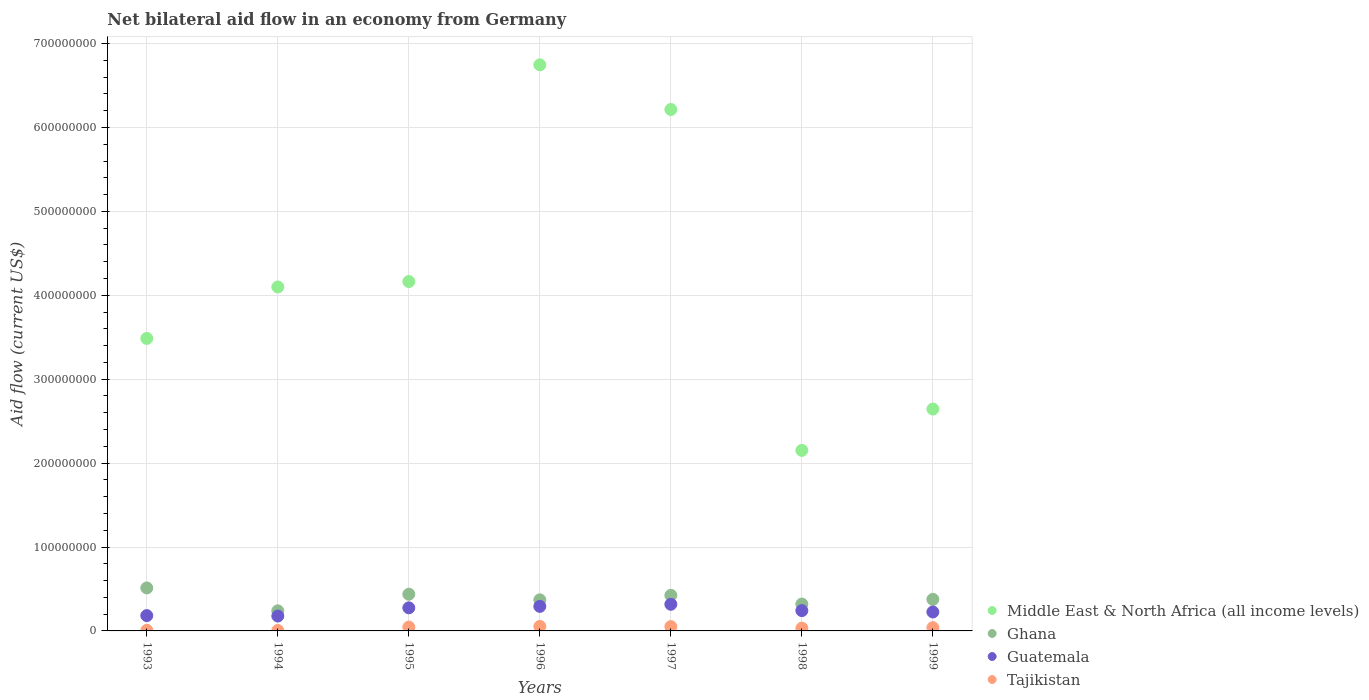How many different coloured dotlines are there?
Your response must be concise. 4. What is the net bilateral aid flow in Guatemala in 1999?
Your answer should be compact. 2.26e+07. Across all years, what is the maximum net bilateral aid flow in Ghana?
Make the answer very short. 5.12e+07. In which year was the net bilateral aid flow in Tajikistan minimum?
Give a very brief answer. 1994. What is the total net bilateral aid flow in Middle East & North Africa (all income levels) in the graph?
Your answer should be very brief. 2.95e+09. What is the difference between the net bilateral aid flow in Tajikistan in 1993 and that in 1996?
Offer a terse response. -4.63e+06. What is the difference between the net bilateral aid flow in Tajikistan in 1994 and the net bilateral aid flow in Middle East & North Africa (all income levels) in 1995?
Keep it short and to the point. -4.16e+08. What is the average net bilateral aid flow in Middle East & North Africa (all income levels) per year?
Your answer should be very brief. 4.21e+08. In the year 1994, what is the difference between the net bilateral aid flow in Guatemala and net bilateral aid flow in Tajikistan?
Provide a succinct answer. 1.72e+07. What is the ratio of the net bilateral aid flow in Guatemala in 1994 to that in 1999?
Your answer should be compact. 0.78. What is the difference between the highest and the second highest net bilateral aid flow in Guatemala?
Your answer should be very brief. 2.49e+06. What is the difference between the highest and the lowest net bilateral aid flow in Ghana?
Your answer should be very brief. 2.73e+07. Is it the case that in every year, the sum of the net bilateral aid flow in Middle East & North Africa (all income levels) and net bilateral aid flow in Guatemala  is greater than the net bilateral aid flow in Tajikistan?
Offer a terse response. Yes. Does the net bilateral aid flow in Middle East & North Africa (all income levels) monotonically increase over the years?
Your answer should be compact. No. Are the values on the major ticks of Y-axis written in scientific E-notation?
Provide a succinct answer. No. Does the graph contain any zero values?
Keep it short and to the point. No. How are the legend labels stacked?
Offer a terse response. Vertical. What is the title of the graph?
Provide a succinct answer. Net bilateral aid flow in an economy from Germany. What is the label or title of the X-axis?
Make the answer very short. Years. What is the label or title of the Y-axis?
Ensure brevity in your answer.  Aid flow (current US$). What is the Aid flow (current US$) of Middle East & North Africa (all income levels) in 1993?
Offer a terse response. 3.49e+08. What is the Aid flow (current US$) in Ghana in 1993?
Your answer should be very brief. 5.12e+07. What is the Aid flow (current US$) of Guatemala in 1993?
Give a very brief answer. 1.83e+07. What is the Aid flow (current US$) of Tajikistan in 1993?
Provide a short and direct response. 7.40e+05. What is the Aid flow (current US$) of Middle East & North Africa (all income levels) in 1994?
Your answer should be very brief. 4.10e+08. What is the Aid flow (current US$) in Ghana in 1994?
Give a very brief answer. 2.39e+07. What is the Aid flow (current US$) in Guatemala in 1994?
Provide a short and direct response. 1.77e+07. What is the Aid flow (current US$) of Tajikistan in 1994?
Make the answer very short. 5.50e+05. What is the Aid flow (current US$) of Middle East & North Africa (all income levels) in 1995?
Your answer should be compact. 4.16e+08. What is the Aid flow (current US$) in Ghana in 1995?
Offer a terse response. 4.37e+07. What is the Aid flow (current US$) in Guatemala in 1995?
Keep it short and to the point. 2.75e+07. What is the Aid flow (current US$) of Tajikistan in 1995?
Make the answer very short. 4.62e+06. What is the Aid flow (current US$) in Middle East & North Africa (all income levels) in 1996?
Make the answer very short. 6.75e+08. What is the Aid flow (current US$) in Ghana in 1996?
Ensure brevity in your answer.  3.71e+07. What is the Aid flow (current US$) of Guatemala in 1996?
Provide a short and direct response. 2.92e+07. What is the Aid flow (current US$) of Tajikistan in 1996?
Ensure brevity in your answer.  5.37e+06. What is the Aid flow (current US$) of Middle East & North Africa (all income levels) in 1997?
Keep it short and to the point. 6.21e+08. What is the Aid flow (current US$) in Ghana in 1997?
Make the answer very short. 4.24e+07. What is the Aid flow (current US$) in Guatemala in 1997?
Offer a very short reply. 3.17e+07. What is the Aid flow (current US$) of Tajikistan in 1997?
Make the answer very short. 5.13e+06. What is the Aid flow (current US$) in Middle East & North Africa (all income levels) in 1998?
Keep it short and to the point. 2.15e+08. What is the Aid flow (current US$) of Ghana in 1998?
Offer a very short reply. 3.20e+07. What is the Aid flow (current US$) in Guatemala in 1998?
Give a very brief answer. 2.42e+07. What is the Aid flow (current US$) in Tajikistan in 1998?
Provide a short and direct response. 3.32e+06. What is the Aid flow (current US$) of Middle East & North Africa (all income levels) in 1999?
Provide a succinct answer. 2.64e+08. What is the Aid flow (current US$) in Ghana in 1999?
Your answer should be compact. 3.76e+07. What is the Aid flow (current US$) in Guatemala in 1999?
Your answer should be compact. 2.26e+07. What is the Aid flow (current US$) in Tajikistan in 1999?
Provide a short and direct response. 3.91e+06. Across all years, what is the maximum Aid flow (current US$) of Middle East & North Africa (all income levels)?
Your answer should be compact. 6.75e+08. Across all years, what is the maximum Aid flow (current US$) in Ghana?
Give a very brief answer. 5.12e+07. Across all years, what is the maximum Aid flow (current US$) of Guatemala?
Your answer should be compact. 3.17e+07. Across all years, what is the maximum Aid flow (current US$) of Tajikistan?
Provide a succinct answer. 5.37e+06. Across all years, what is the minimum Aid flow (current US$) in Middle East & North Africa (all income levels)?
Give a very brief answer. 2.15e+08. Across all years, what is the minimum Aid flow (current US$) in Ghana?
Ensure brevity in your answer.  2.39e+07. Across all years, what is the minimum Aid flow (current US$) in Guatemala?
Ensure brevity in your answer.  1.77e+07. What is the total Aid flow (current US$) of Middle East & North Africa (all income levels) in the graph?
Your response must be concise. 2.95e+09. What is the total Aid flow (current US$) of Ghana in the graph?
Make the answer very short. 2.68e+08. What is the total Aid flow (current US$) of Guatemala in the graph?
Your answer should be very brief. 1.71e+08. What is the total Aid flow (current US$) in Tajikistan in the graph?
Provide a short and direct response. 2.36e+07. What is the difference between the Aid flow (current US$) in Middle East & North Africa (all income levels) in 1993 and that in 1994?
Make the answer very short. -6.13e+07. What is the difference between the Aid flow (current US$) of Ghana in 1993 and that in 1994?
Ensure brevity in your answer.  2.73e+07. What is the difference between the Aid flow (current US$) of Guatemala in 1993 and that in 1994?
Ensure brevity in your answer.  5.30e+05. What is the difference between the Aid flow (current US$) of Tajikistan in 1993 and that in 1994?
Your response must be concise. 1.90e+05. What is the difference between the Aid flow (current US$) of Middle East & North Africa (all income levels) in 1993 and that in 1995?
Keep it short and to the point. -6.78e+07. What is the difference between the Aid flow (current US$) in Ghana in 1993 and that in 1995?
Offer a terse response. 7.49e+06. What is the difference between the Aid flow (current US$) of Guatemala in 1993 and that in 1995?
Keep it short and to the point. -9.24e+06. What is the difference between the Aid flow (current US$) in Tajikistan in 1993 and that in 1995?
Your answer should be compact. -3.88e+06. What is the difference between the Aid flow (current US$) of Middle East & North Africa (all income levels) in 1993 and that in 1996?
Offer a terse response. -3.26e+08. What is the difference between the Aid flow (current US$) of Ghana in 1993 and that in 1996?
Provide a succinct answer. 1.42e+07. What is the difference between the Aid flow (current US$) of Guatemala in 1993 and that in 1996?
Offer a very short reply. -1.10e+07. What is the difference between the Aid flow (current US$) in Tajikistan in 1993 and that in 1996?
Make the answer very short. -4.63e+06. What is the difference between the Aid flow (current US$) in Middle East & North Africa (all income levels) in 1993 and that in 1997?
Offer a terse response. -2.73e+08. What is the difference between the Aid flow (current US$) of Ghana in 1993 and that in 1997?
Give a very brief answer. 8.83e+06. What is the difference between the Aid flow (current US$) in Guatemala in 1993 and that in 1997?
Provide a short and direct response. -1.35e+07. What is the difference between the Aid flow (current US$) in Tajikistan in 1993 and that in 1997?
Offer a very short reply. -4.39e+06. What is the difference between the Aid flow (current US$) in Middle East & North Africa (all income levels) in 1993 and that in 1998?
Your answer should be compact. 1.33e+08. What is the difference between the Aid flow (current US$) in Ghana in 1993 and that in 1998?
Your answer should be compact. 1.92e+07. What is the difference between the Aid flow (current US$) in Guatemala in 1993 and that in 1998?
Offer a terse response. -5.94e+06. What is the difference between the Aid flow (current US$) in Tajikistan in 1993 and that in 1998?
Offer a very short reply. -2.58e+06. What is the difference between the Aid flow (current US$) of Middle East & North Africa (all income levels) in 1993 and that in 1999?
Your answer should be compact. 8.42e+07. What is the difference between the Aid flow (current US$) in Ghana in 1993 and that in 1999?
Make the answer very short. 1.36e+07. What is the difference between the Aid flow (current US$) in Guatemala in 1993 and that in 1999?
Offer a terse response. -4.33e+06. What is the difference between the Aid flow (current US$) of Tajikistan in 1993 and that in 1999?
Provide a short and direct response. -3.17e+06. What is the difference between the Aid flow (current US$) in Middle East & North Africa (all income levels) in 1994 and that in 1995?
Your response must be concise. -6.46e+06. What is the difference between the Aid flow (current US$) in Ghana in 1994 and that in 1995?
Keep it short and to the point. -1.98e+07. What is the difference between the Aid flow (current US$) in Guatemala in 1994 and that in 1995?
Keep it short and to the point. -9.77e+06. What is the difference between the Aid flow (current US$) in Tajikistan in 1994 and that in 1995?
Provide a succinct answer. -4.07e+06. What is the difference between the Aid flow (current US$) of Middle East & North Africa (all income levels) in 1994 and that in 1996?
Your answer should be very brief. -2.65e+08. What is the difference between the Aid flow (current US$) in Ghana in 1994 and that in 1996?
Provide a short and direct response. -1.31e+07. What is the difference between the Aid flow (current US$) of Guatemala in 1994 and that in 1996?
Keep it short and to the point. -1.15e+07. What is the difference between the Aid flow (current US$) in Tajikistan in 1994 and that in 1996?
Provide a short and direct response. -4.82e+06. What is the difference between the Aid flow (current US$) of Middle East & North Africa (all income levels) in 1994 and that in 1997?
Your response must be concise. -2.11e+08. What is the difference between the Aid flow (current US$) of Ghana in 1994 and that in 1997?
Your response must be concise. -1.85e+07. What is the difference between the Aid flow (current US$) in Guatemala in 1994 and that in 1997?
Give a very brief answer. -1.40e+07. What is the difference between the Aid flow (current US$) in Tajikistan in 1994 and that in 1997?
Offer a terse response. -4.58e+06. What is the difference between the Aid flow (current US$) in Middle East & North Africa (all income levels) in 1994 and that in 1998?
Make the answer very short. 1.95e+08. What is the difference between the Aid flow (current US$) in Ghana in 1994 and that in 1998?
Provide a short and direct response. -8.13e+06. What is the difference between the Aid flow (current US$) of Guatemala in 1994 and that in 1998?
Offer a terse response. -6.47e+06. What is the difference between the Aid flow (current US$) in Tajikistan in 1994 and that in 1998?
Provide a short and direct response. -2.77e+06. What is the difference between the Aid flow (current US$) of Middle East & North Africa (all income levels) in 1994 and that in 1999?
Give a very brief answer. 1.45e+08. What is the difference between the Aid flow (current US$) of Ghana in 1994 and that in 1999?
Keep it short and to the point. -1.37e+07. What is the difference between the Aid flow (current US$) in Guatemala in 1994 and that in 1999?
Keep it short and to the point. -4.86e+06. What is the difference between the Aid flow (current US$) of Tajikistan in 1994 and that in 1999?
Provide a succinct answer. -3.36e+06. What is the difference between the Aid flow (current US$) in Middle East & North Africa (all income levels) in 1995 and that in 1996?
Your answer should be very brief. -2.58e+08. What is the difference between the Aid flow (current US$) in Ghana in 1995 and that in 1996?
Keep it short and to the point. 6.68e+06. What is the difference between the Aid flow (current US$) of Guatemala in 1995 and that in 1996?
Give a very brief answer. -1.75e+06. What is the difference between the Aid flow (current US$) of Tajikistan in 1995 and that in 1996?
Your answer should be compact. -7.50e+05. What is the difference between the Aid flow (current US$) of Middle East & North Africa (all income levels) in 1995 and that in 1997?
Ensure brevity in your answer.  -2.05e+08. What is the difference between the Aid flow (current US$) in Ghana in 1995 and that in 1997?
Give a very brief answer. 1.34e+06. What is the difference between the Aid flow (current US$) in Guatemala in 1995 and that in 1997?
Make the answer very short. -4.24e+06. What is the difference between the Aid flow (current US$) in Tajikistan in 1995 and that in 1997?
Your answer should be compact. -5.10e+05. What is the difference between the Aid flow (current US$) of Middle East & North Africa (all income levels) in 1995 and that in 1998?
Provide a short and direct response. 2.01e+08. What is the difference between the Aid flow (current US$) of Ghana in 1995 and that in 1998?
Your response must be concise. 1.17e+07. What is the difference between the Aid flow (current US$) in Guatemala in 1995 and that in 1998?
Keep it short and to the point. 3.30e+06. What is the difference between the Aid flow (current US$) in Tajikistan in 1995 and that in 1998?
Ensure brevity in your answer.  1.30e+06. What is the difference between the Aid flow (current US$) in Middle East & North Africa (all income levels) in 1995 and that in 1999?
Give a very brief answer. 1.52e+08. What is the difference between the Aid flow (current US$) in Ghana in 1995 and that in 1999?
Provide a succinct answer. 6.14e+06. What is the difference between the Aid flow (current US$) in Guatemala in 1995 and that in 1999?
Give a very brief answer. 4.91e+06. What is the difference between the Aid flow (current US$) of Tajikistan in 1995 and that in 1999?
Provide a short and direct response. 7.10e+05. What is the difference between the Aid flow (current US$) of Middle East & North Africa (all income levels) in 1996 and that in 1997?
Offer a very short reply. 5.32e+07. What is the difference between the Aid flow (current US$) in Ghana in 1996 and that in 1997?
Your response must be concise. -5.34e+06. What is the difference between the Aid flow (current US$) of Guatemala in 1996 and that in 1997?
Offer a very short reply. -2.49e+06. What is the difference between the Aid flow (current US$) of Middle East & North Africa (all income levels) in 1996 and that in 1998?
Ensure brevity in your answer.  4.59e+08. What is the difference between the Aid flow (current US$) in Ghana in 1996 and that in 1998?
Your response must be concise. 5.01e+06. What is the difference between the Aid flow (current US$) in Guatemala in 1996 and that in 1998?
Give a very brief answer. 5.05e+06. What is the difference between the Aid flow (current US$) in Tajikistan in 1996 and that in 1998?
Your response must be concise. 2.05e+06. What is the difference between the Aid flow (current US$) in Middle East & North Africa (all income levels) in 1996 and that in 1999?
Give a very brief answer. 4.10e+08. What is the difference between the Aid flow (current US$) of Ghana in 1996 and that in 1999?
Your answer should be very brief. -5.40e+05. What is the difference between the Aid flow (current US$) in Guatemala in 1996 and that in 1999?
Offer a terse response. 6.66e+06. What is the difference between the Aid flow (current US$) in Tajikistan in 1996 and that in 1999?
Keep it short and to the point. 1.46e+06. What is the difference between the Aid flow (current US$) in Middle East & North Africa (all income levels) in 1997 and that in 1998?
Your answer should be very brief. 4.06e+08. What is the difference between the Aid flow (current US$) in Ghana in 1997 and that in 1998?
Provide a short and direct response. 1.04e+07. What is the difference between the Aid flow (current US$) in Guatemala in 1997 and that in 1998?
Make the answer very short. 7.54e+06. What is the difference between the Aid flow (current US$) of Tajikistan in 1997 and that in 1998?
Your response must be concise. 1.81e+06. What is the difference between the Aid flow (current US$) in Middle East & North Africa (all income levels) in 1997 and that in 1999?
Give a very brief answer. 3.57e+08. What is the difference between the Aid flow (current US$) in Ghana in 1997 and that in 1999?
Your answer should be very brief. 4.80e+06. What is the difference between the Aid flow (current US$) of Guatemala in 1997 and that in 1999?
Provide a succinct answer. 9.15e+06. What is the difference between the Aid flow (current US$) in Tajikistan in 1997 and that in 1999?
Provide a succinct answer. 1.22e+06. What is the difference between the Aid flow (current US$) in Middle East & North Africa (all income levels) in 1998 and that in 1999?
Ensure brevity in your answer.  -4.93e+07. What is the difference between the Aid flow (current US$) of Ghana in 1998 and that in 1999?
Your response must be concise. -5.55e+06. What is the difference between the Aid flow (current US$) in Guatemala in 1998 and that in 1999?
Your answer should be compact. 1.61e+06. What is the difference between the Aid flow (current US$) in Tajikistan in 1998 and that in 1999?
Offer a very short reply. -5.90e+05. What is the difference between the Aid flow (current US$) in Middle East & North Africa (all income levels) in 1993 and the Aid flow (current US$) in Ghana in 1994?
Your answer should be compact. 3.25e+08. What is the difference between the Aid flow (current US$) of Middle East & North Africa (all income levels) in 1993 and the Aid flow (current US$) of Guatemala in 1994?
Offer a terse response. 3.31e+08. What is the difference between the Aid flow (current US$) in Middle East & North Africa (all income levels) in 1993 and the Aid flow (current US$) in Tajikistan in 1994?
Your answer should be compact. 3.48e+08. What is the difference between the Aid flow (current US$) of Ghana in 1993 and the Aid flow (current US$) of Guatemala in 1994?
Make the answer very short. 3.35e+07. What is the difference between the Aid flow (current US$) in Ghana in 1993 and the Aid flow (current US$) in Tajikistan in 1994?
Keep it short and to the point. 5.07e+07. What is the difference between the Aid flow (current US$) of Guatemala in 1993 and the Aid flow (current US$) of Tajikistan in 1994?
Your response must be concise. 1.77e+07. What is the difference between the Aid flow (current US$) in Middle East & North Africa (all income levels) in 1993 and the Aid flow (current US$) in Ghana in 1995?
Your answer should be compact. 3.05e+08. What is the difference between the Aid flow (current US$) in Middle East & North Africa (all income levels) in 1993 and the Aid flow (current US$) in Guatemala in 1995?
Provide a short and direct response. 3.21e+08. What is the difference between the Aid flow (current US$) of Middle East & North Africa (all income levels) in 1993 and the Aid flow (current US$) of Tajikistan in 1995?
Make the answer very short. 3.44e+08. What is the difference between the Aid flow (current US$) of Ghana in 1993 and the Aid flow (current US$) of Guatemala in 1995?
Provide a short and direct response. 2.37e+07. What is the difference between the Aid flow (current US$) in Ghana in 1993 and the Aid flow (current US$) in Tajikistan in 1995?
Make the answer very short. 4.66e+07. What is the difference between the Aid flow (current US$) in Guatemala in 1993 and the Aid flow (current US$) in Tajikistan in 1995?
Offer a very short reply. 1.36e+07. What is the difference between the Aid flow (current US$) in Middle East & North Africa (all income levels) in 1993 and the Aid flow (current US$) in Ghana in 1996?
Your answer should be very brief. 3.12e+08. What is the difference between the Aid flow (current US$) in Middle East & North Africa (all income levels) in 1993 and the Aid flow (current US$) in Guatemala in 1996?
Your response must be concise. 3.19e+08. What is the difference between the Aid flow (current US$) of Middle East & North Africa (all income levels) in 1993 and the Aid flow (current US$) of Tajikistan in 1996?
Provide a short and direct response. 3.43e+08. What is the difference between the Aid flow (current US$) in Ghana in 1993 and the Aid flow (current US$) in Guatemala in 1996?
Provide a short and direct response. 2.20e+07. What is the difference between the Aid flow (current US$) of Ghana in 1993 and the Aid flow (current US$) of Tajikistan in 1996?
Your answer should be compact. 4.59e+07. What is the difference between the Aid flow (current US$) in Guatemala in 1993 and the Aid flow (current US$) in Tajikistan in 1996?
Keep it short and to the point. 1.29e+07. What is the difference between the Aid flow (current US$) in Middle East & North Africa (all income levels) in 1993 and the Aid flow (current US$) in Ghana in 1997?
Give a very brief answer. 3.06e+08. What is the difference between the Aid flow (current US$) in Middle East & North Africa (all income levels) in 1993 and the Aid flow (current US$) in Guatemala in 1997?
Give a very brief answer. 3.17e+08. What is the difference between the Aid flow (current US$) in Middle East & North Africa (all income levels) in 1993 and the Aid flow (current US$) in Tajikistan in 1997?
Make the answer very short. 3.43e+08. What is the difference between the Aid flow (current US$) in Ghana in 1993 and the Aid flow (current US$) in Guatemala in 1997?
Ensure brevity in your answer.  1.95e+07. What is the difference between the Aid flow (current US$) of Ghana in 1993 and the Aid flow (current US$) of Tajikistan in 1997?
Give a very brief answer. 4.61e+07. What is the difference between the Aid flow (current US$) in Guatemala in 1993 and the Aid flow (current US$) in Tajikistan in 1997?
Ensure brevity in your answer.  1.31e+07. What is the difference between the Aid flow (current US$) in Middle East & North Africa (all income levels) in 1993 and the Aid flow (current US$) in Ghana in 1998?
Your answer should be very brief. 3.17e+08. What is the difference between the Aid flow (current US$) of Middle East & North Africa (all income levels) in 1993 and the Aid flow (current US$) of Guatemala in 1998?
Your answer should be very brief. 3.24e+08. What is the difference between the Aid flow (current US$) in Middle East & North Africa (all income levels) in 1993 and the Aid flow (current US$) in Tajikistan in 1998?
Your answer should be compact. 3.45e+08. What is the difference between the Aid flow (current US$) in Ghana in 1993 and the Aid flow (current US$) in Guatemala in 1998?
Give a very brief answer. 2.70e+07. What is the difference between the Aid flow (current US$) of Ghana in 1993 and the Aid flow (current US$) of Tajikistan in 1998?
Provide a succinct answer. 4.79e+07. What is the difference between the Aid flow (current US$) of Guatemala in 1993 and the Aid flow (current US$) of Tajikistan in 1998?
Make the answer very short. 1.49e+07. What is the difference between the Aid flow (current US$) in Middle East & North Africa (all income levels) in 1993 and the Aid flow (current US$) in Ghana in 1999?
Give a very brief answer. 3.11e+08. What is the difference between the Aid flow (current US$) in Middle East & North Africa (all income levels) in 1993 and the Aid flow (current US$) in Guatemala in 1999?
Your response must be concise. 3.26e+08. What is the difference between the Aid flow (current US$) of Middle East & North Africa (all income levels) in 1993 and the Aid flow (current US$) of Tajikistan in 1999?
Your response must be concise. 3.45e+08. What is the difference between the Aid flow (current US$) of Ghana in 1993 and the Aid flow (current US$) of Guatemala in 1999?
Give a very brief answer. 2.86e+07. What is the difference between the Aid flow (current US$) in Ghana in 1993 and the Aid flow (current US$) in Tajikistan in 1999?
Make the answer very short. 4.73e+07. What is the difference between the Aid flow (current US$) in Guatemala in 1993 and the Aid flow (current US$) in Tajikistan in 1999?
Your response must be concise. 1.44e+07. What is the difference between the Aid flow (current US$) in Middle East & North Africa (all income levels) in 1994 and the Aid flow (current US$) in Ghana in 1995?
Make the answer very short. 3.66e+08. What is the difference between the Aid flow (current US$) in Middle East & North Africa (all income levels) in 1994 and the Aid flow (current US$) in Guatemala in 1995?
Keep it short and to the point. 3.82e+08. What is the difference between the Aid flow (current US$) of Middle East & North Africa (all income levels) in 1994 and the Aid flow (current US$) of Tajikistan in 1995?
Keep it short and to the point. 4.05e+08. What is the difference between the Aid flow (current US$) of Ghana in 1994 and the Aid flow (current US$) of Guatemala in 1995?
Keep it short and to the point. -3.58e+06. What is the difference between the Aid flow (current US$) in Ghana in 1994 and the Aid flow (current US$) in Tajikistan in 1995?
Offer a very short reply. 1.93e+07. What is the difference between the Aid flow (current US$) in Guatemala in 1994 and the Aid flow (current US$) in Tajikistan in 1995?
Your answer should be very brief. 1.31e+07. What is the difference between the Aid flow (current US$) of Middle East & North Africa (all income levels) in 1994 and the Aid flow (current US$) of Ghana in 1996?
Keep it short and to the point. 3.73e+08. What is the difference between the Aid flow (current US$) in Middle East & North Africa (all income levels) in 1994 and the Aid flow (current US$) in Guatemala in 1996?
Your answer should be compact. 3.81e+08. What is the difference between the Aid flow (current US$) of Middle East & North Africa (all income levels) in 1994 and the Aid flow (current US$) of Tajikistan in 1996?
Ensure brevity in your answer.  4.05e+08. What is the difference between the Aid flow (current US$) of Ghana in 1994 and the Aid flow (current US$) of Guatemala in 1996?
Provide a short and direct response. -5.33e+06. What is the difference between the Aid flow (current US$) in Ghana in 1994 and the Aid flow (current US$) in Tajikistan in 1996?
Offer a very short reply. 1.86e+07. What is the difference between the Aid flow (current US$) in Guatemala in 1994 and the Aid flow (current US$) in Tajikistan in 1996?
Provide a succinct answer. 1.24e+07. What is the difference between the Aid flow (current US$) in Middle East & North Africa (all income levels) in 1994 and the Aid flow (current US$) in Ghana in 1997?
Provide a succinct answer. 3.68e+08. What is the difference between the Aid flow (current US$) in Middle East & North Africa (all income levels) in 1994 and the Aid flow (current US$) in Guatemala in 1997?
Offer a terse response. 3.78e+08. What is the difference between the Aid flow (current US$) of Middle East & North Africa (all income levels) in 1994 and the Aid flow (current US$) of Tajikistan in 1997?
Ensure brevity in your answer.  4.05e+08. What is the difference between the Aid flow (current US$) in Ghana in 1994 and the Aid flow (current US$) in Guatemala in 1997?
Offer a very short reply. -7.82e+06. What is the difference between the Aid flow (current US$) in Ghana in 1994 and the Aid flow (current US$) in Tajikistan in 1997?
Your response must be concise. 1.88e+07. What is the difference between the Aid flow (current US$) in Guatemala in 1994 and the Aid flow (current US$) in Tajikistan in 1997?
Provide a short and direct response. 1.26e+07. What is the difference between the Aid flow (current US$) in Middle East & North Africa (all income levels) in 1994 and the Aid flow (current US$) in Ghana in 1998?
Provide a short and direct response. 3.78e+08. What is the difference between the Aid flow (current US$) of Middle East & North Africa (all income levels) in 1994 and the Aid flow (current US$) of Guatemala in 1998?
Your response must be concise. 3.86e+08. What is the difference between the Aid flow (current US$) in Middle East & North Africa (all income levels) in 1994 and the Aid flow (current US$) in Tajikistan in 1998?
Provide a succinct answer. 4.07e+08. What is the difference between the Aid flow (current US$) in Ghana in 1994 and the Aid flow (current US$) in Guatemala in 1998?
Offer a very short reply. -2.80e+05. What is the difference between the Aid flow (current US$) in Ghana in 1994 and the Aid flow (current US$) in Tajikistan in 1998?
Offer a terse response. 2.06e+07. What is the difference between the Aid flow (current US$) of Guatemala in 1994 and the Aid flow (current US$) of Tajikistan in 1998?
Give a very brief answer. 1.44e+07. What is the difference between the Aid flow (current US$) of Middle East & North Africa (all income levels) in 1994 and the Aid flow (current US$) of Ghana in 1999?
Make the answer very short. 3.72e+08. What is the difference between the Aid flow (current US$) in Middle East & North Africa (all income levels) in 1994 and the Aid flow (current US$) in Guatemala in 1999?
Ensure brevity in your answer.  3.87e+08. What is the difference between the Aid flow (current US$) of Middle East & North Africa (all income levels) in 1994 and the Aid flow (current US$) of Tajikistan in 1999?
Give a very brief answer. 4.06e+08. What is the difference between the Aid flow (current US$) of Ghana in 1994 and the Aid flow (current US$) of Guatemala in 1999?
Offer a terse response. 1.33e+06. What is the difference between the Aid flow (current US$) in Ghana in 1994 and the Aid flow (current US$) in Tajikistan in 1999?
Keep it short and to the point. 2.00e+07. What is the difference between the Aid flow (current US$) in Guatemala in 1994 and the Aid flow (current US$) in Tajikistan in 1999?
Provide a succinct answer. 1.38e+07. What is the difference between the Aid flow (current US$) in Middle East & North Africa (all income levels) in 1995 and the Aid flow (current US$) in Ghana in 1996?
Your answer should be compact. 3.79e+08. What is the difference between the Aid flow (current US$) of Middle East & North Africa (all income levels) in 1995 and the Aid flow (current US$) of Guatemala in 1996?
Your response must be concise. 3.87e+08. What is the difference between the Aid flow (current US$) of Middle East & North Africa (all income levels) in 1995 and the Aid flow (current US$) of Tajikistan in 1996?
Provide a short and direct response. 4.11e+08. What is the difference between the Aid flow (current US$) of Ghana in 1995 and the Aid flow (current US$) of Guatemala in 1996?
Offer a terse response. 1.45e+07. What is the difference between the Aid flow (current US$) of Ghana in 1995 and the Aid flow (current US$) of Tajikistan in 1996?
Offer a terse response. 3.84e+07. What is the difference between the Aid flow (current US$) in Guatemala in 1995 and the Aid flow (current US$) in Tajikistan in 1996?
Offer a very short reply. 2.21e+07. What is the difference between the Aid flow (current US$) of Middle East & North Africa (all income levels) in 1995 and the Aid flow (current US$) of Ghana in 1997?
Your response must be concise. 3.74e+08. What is the difference between the Aid flow (current US$) of Middle East & North Africa (all income levels) in 1995 and the Aid flow (current US$) of Guatemala in 1997?
Give a very brief answer. 3.85e+08. What is the difference between the Aid flow (current US$) of Middle East & North Africa (all income levels) in 1995 and the Aid flow (current US$) of Tajikistan in 1997?
Offer a terse response. 4.11e+08. What is the difference between the Aid flow (current US$) in Ghana in 1995 and the Aid flow (current US$) in Tajikistan in 1997?
Your answer should be compact. 3.86e+07. What is the difference between the Aid flow (current US$) in Guatemala in 1995 and the Aid flow (current US$) in Tajikistan in 1997?
Provide a succinct answer. 2.24e+07. What is the difference between the Aid flow (current US$) in Middle East & North Africa (all income levels) in 1995 and the Aid flow (current US$) in Ghana in 1998?
Ensure brevity in your answer.  3.84e+08. What is the difference between the Aid flow (current US$) of Middle East & North Africa (all income levels) in 1995 and the Aid flow (current US$) of Guatemala in 1998?
Provide a short and direct response. 3.92e+08. What is the difference between the Aid flow (current US$) of Middle East & North Africa (all income levels) in 1995 and the Aid flow (current US$) of Tajikistan in 1998?
Provide a short and direct response. 4.13e+08. What is the difference between the Aid flow (current US$) in Ghana in 1995 and the Aid flow (current US$) in Guatemala in 1998?
Your answer should be compact. 1.95e+07. What is the difference between the Aid flow (current US$) of Ghana in 1995 and the Aid flow (current US$) of Tajikistan in 1998?
Your response must be concise. 4.04e+07. What is the difference between the Aid flow (current US$) of Guatemala in 1995 and the Aid flow (current US$) of Tajikistan in 1998?
Offer a terse response. 2.42e+07. What is the difference between the Aid flow (current US$) of Middle East & North Africa (all income levels) in 1995 and the Aid flow (current US$) of Ghana in 1999?
Your answer should be very brief. 3.79e+08. What is the difference between the Aid flow (current US$) in Middle East & North Africa (all income levels) in 1995 and the Aid flow (current US$) in Guatemala in 1999?
Your answer should be very brief. 3.94e+08. What is the difference between the Aid flow (current US$) in Middle East & North Africa (all income levels) in 1995 and the Aid flow (current US$) in Tajikistan in 1999?
Provide a succinct answer. 4.12e+08. What is the difference between the Aid flow (current US$) of Ghana in 1995 and the Aid flow (current US$) of Guatemala in 1999?
Keep it short and to the point. 2.12e+07. What is the difference between the Aid flow (current US$) of Ghana in 1995 and the Aid flow (current US$) of Tajikistan in 1999?
Ensure brevity in your answer.  3.98e+07. What is the difference between the Aid flow (current US$) in Guatemala in 1995 and the Aid flow (current US$) in Tajikistan in 1999?
Your answer should be very brief. 2.36e+07. What is the difference between the Aid flow (current US$) of Middle East & North Africa (all income levels) in 1996 and the Aid flow (current US$) of Ghana in 1997?
Provide a short and direct response. 6.32e+08. What is the difference between the Aid flow (current US$) of Middle East & North Africa (all income levels) in 1996 and the Aid flow (current US$) of Guatemala in 1997?
Make the answer very short. 6.43e+08. What is the difference between the Aid flow (current US$) in Middle East & North Africa (all income levels) in 1996 and the Aid flow (current US$) in Tajikistan in 1997?
Make the answer very short. 6.69e+08. What is the difference between the Aid flow (current US$) in Ghana in 1996 and the Aid flow (current US$) in Guatemala in 1997?
Keep it short and to the point. 5.32e+06. What is the difference between the Aid flow (current US$) of Ghana in 1996 and the Aid flow (current US$) of Tajikistan in 1997?
Your answer should be very brief. 3.19e+07. What is the difference between the Aid flow (current US$) in Guatemala in 1996 and the Aid flow (current US$) in Tajikistan in 1997?
Your answer should be compact. 2.41e+07. What is the difference between the Aid flow (current US$) of Middle East & North Africa (all income levels) in 1996 and the Aid flow (current US$) of Ghana in 1998?
Keep it short and to the point. 6.43e+08. What is the difference between the Aid flow (current US$) in Middle East & North Africa (all income levels) in 1996 and the Aid flow (current US$) in Guatemala in 1998?
Provide a succinct answer. 6.50e+08. What is the difference between the Aid flow (current US$) of Middle East & North Africa (all income levels) in 1996 and the Aid flow (current US$) of Tajikistan in 1998?
Your answer should be compact. 6.71e+08. What is the difference between the Aid flow (current US$) in Ghana in 1996 and the Aid flow (current US$) in Guatemala in 1998?
Offer a very short reply. 1.29e+07. What is the difference between the Aid flow (current US$) of Ghana in 1996 and the Aid flow (current US$) of Tajikistan in 1998?
Provide a succinct answer. 3.37e+07. What is the difference between the Aid flow (current US$) of Guatemala in 1996 and the Aid flow (current US$) of Tajikistan in 1998?
Ensure brevity in your answer.  2.59e+07. What is the difference between the Aid flow (current US$) of Middle East & North Africa (all income levels) in 1996 and the Aid flow (current US$) of Ghana in 1999?
Your response must be concise. 6.37e+08. What is the difference between the Aid flow (current US$) in Middle East & North Africa (all income levels) in 1996 and the Aid flow (current US$) in Guatemala in 1999?
Provide a succinct answer. 6.52e+08. What is the difference between the Aid flow (current US$) of Middle East & North Africa (all income levels) in 1996 and the Aid flow (current US$) of Tajikistan in 1999?
Provide a succinct answer. 6.71e+08. What is the difference between the Aid flow (current US$) in Ghana in 1996 and the Aid flow (current US$) in Guatemala in 1999?
Your answer should be compact. 1.45e+07. What is the difference between the Aid flow (current US$) in Ghana in 1996 and the Aid flow (current US$) in Tajikistan in 1999?
Provide a succinct answer. 3.32e+07. What is the difference between the Aid flow (current US$) in Guatemala in 1996 and the Aid flow (current US$) in Tajikistan in 1999?
Provide a short and direct response. 2.53e+07. What is the difference between the Aid flow (current US$) in Middle East & North Africa (all income levels) in 1997 and the Aid flow (current US$) in Ghana in 1998?
Your answer should be very brief. 5.89e+08. What is the difference between the Aid flow (current US$) of Middle East & North Africa (all income levels) in 1997 and the Aid flow (current US$) of Guatemala in 1998?
Your response must be concise. 5.97e+08. What is the difference between the Aid flow (current US$) of Middle East & North Africa (all income levels) in 1997 and the Aid flow (current US$) of Tajikistan in 1998?
Provide a succinct answer. 6.18e+08. What is the difference between the Aid flow (current US$) in Ghana in 1997 and the Aid flow (current US$) in Guatemala in 1998?
Your response must be concise. 1.82e+07. What is the difference between the Aid flow (current US$) in Ghana in 1997 and the Aid flow (current US$) in Tajikistan in 1998?
Offer a very short reply. 3.91e+07. What is the difference between the Aid flow (current US$) in Guatemala in 1997 and the Aid flow (current US$) in Tajikistan in 1998?
Provide a short and direct response. 2.84e+07. What is the difference between the Aid flow (current US$) in Middle East & North Africa (all income levels) in 1997 and the Aid flow (current US$) in Ghana in 1999?
Keep it short and to the point. 5.84e+08. What is the difference between the Aid flow (current US$) in Middle East & North Africa (all income levels) in 1997 and the Aid flow (current US$) in Guatemala in 1999?
Offer a very short reply. 5.99e+08. What is the difference between the Aid flow (current US$) of Middle East & North Africa (all income levels) in 1997 and the Aid flow (current US$) of Tajikistan in 1999?
Provide a succinct answer. 6.17e+08. What is the difference between the Aid flow (current US$) of Ghana in 1997 and the Aid flow (current US$) of Guatemala in 1999?
Your answer should be compact. 1.98e+07. What is the difference between the Aid flow (current US$) of Ghana in 1997 and the Aid flow (current US$) of Tajikistan in 1999?
Provide a succinct answer. 3.85e+07. What is the difference between the Aid flow (current US$) of Guatemala in 1997 and the Aid flow (current US$) of Tajikistan in 1999?
Keep it short and to the point. 2.78e+07. What is the difference between the Aid flow (current US$) in Middle East & North Africa (all income levels) in 1998 and the Aid flow (current US$) in Ghana in 1999?
Your answer should be compact. 1.78e+08. What is the difference between the Aid flow (current US$) of Middle East & North Africa (all income levels) in 1998 and the Aid flow (current US$) of Guatemala in 1999?
Your answer should be very brief. 1.93e+08. What is the difference between the Aid flow (current US$) in Middle East & North Africa (all income levels) in 1998 and the Aid flow (current US$) in Tajikistan in 1999?
Provide a short and direct response. 2.11e+08. What is the difference between the Aid flow (current US$) in Ghana in 1998 and the Aid flow (current US$) in Guatemala in 1999?
Provide a succinct answer. 9.46e+06. What is the difference between the Aid flow (current US$) in Ghana in 1998 and the Aid flow (current US$) in Tajikistan in 1999?
Provide a succinct answer. 2.81e+07. What is the difference between the Aid flow (current US$) in Guatemala in 1998 and the Aid flow (current US$) in Tajikistan in 1999?
Your answer should be very brief. 2.03e+07. What is the average Aid flow (current US$) of Middle East & North Africa (all income levels) per year?
Your answer should be very brief. 4.21e+08. What is the average Aid flow (current US$) of Ghana per year?
Your answer should be compact. 3.83e+07. What is the average Aid flow (current US$) of Guatemala per year?
Make the answer very short. 2.45e+07. What is the average Aid flow (current US$) in Tajikistan per year?
Offer a very short reply. 3.38e+06. In the year 1993, what is the difference between the Aid flow (current US$) in Middle East & North Africa (all income levels) and Aid flow (current US$) in Ghana?
Keep it short and to the point. 2.97e+08. In the year 1993, what is the difference between the Aid flow (current US$) of Middle East & North Africa (all income levels) and Aid flow (current US$) of Guatemala?
Give a very brief answer. 3.30e+08. In the year 1993, what is the difference between the Aid flow (current US$) in Middle East & North Africa (all income levels) and Aid flow (current US$) in Tajikistan?
Offer a terse response. 3.48e+08. In the year 1993, what is the difference between the Aid flow (current US$) of Ghana and Aid flow (current US$) of Guatemala?
Provide a succinct answer. 3.30e+07. In the year 1993, what is the difference between the Aid flow (current US$) of Ghana and Aid flow (current US$) of Tajikistan?
Give a very brief answer. 5.05e+07. In the year 1993, what is the difference between the Aid flow (current US$) in Guatemala and Aid flow (current US$) in Tajikistan?
Keep it short and to the point. 1.75e+07. In the year 1994, what is the difference between the Aid flow (current US$) of Middle East & North Africa (all income levels) and Aid flow (current US$) of Ghana?
Give a very brief answer. 3.86e+08. In the year 1994, what is the difference between the Aid flow (current US$) in Middle East & North Africa (all income levels) and Aid flow (current US$) in Guatemala?
Keep it short and to the point. 3.92e+08. In the year 1994, what is the difference between the Aid flow (current US$) of Middle East & North Africa (all income levels) and Aid flow (current US$) of Tajikistan?
Ensure brevity in your answer.  4.09e+08. In the year 1994, what is the difference between the Aid flow (current US$) in Ghana and Aid flow (current US$) in Guatemala?
Provide a short and direct response. 6.19e+06. In the year 1994, what is the difference between the Aid flow (current US$) of Ghana and Aid flow (current US$) of Tajikistan?
Offer a terse response. 2.34e+07. In the year 1994, what is the difference between the Aid flow (current US$) in Guatemala and Aid flow (current US$) in Tajikistan?
Ensure brevity in your answer.  1.72e+07. In the year 1995, what is the difference between the Aid flow (current US$) of Middle East & North Africa (all income levels) and Aid flow (current US$) of Ghana?
Your response must be concise. 3.73e+08. In the year 1995, what is the difference between the Aid flow (current US$) in Middle East & North Africa (all income levels) and Aid flow (current US$) in Guatemala?
Offer a very short reply. 3.89e+08. In the year 1995, what is the difference between the Aid flow (current US$) of Middle East & North Africa (all income levels) and Aid flow (current US$) of Tajikistan?
Offer a very short reply. 4.12e+08. In the year 1995, what is the difference between the Aid flow (current US$) of Ghana and Aid flow (current US$) of Guatemala?
Provide a succinct answer. 1.62e+07. In the year 1995, what is the difference between the Aid flow (current US$) in Ghana and Aid flow (current US$) in Tajikistan?
Your response must be concise. 3.91e+07. In the year 1995, what is the difference between the Aid flow (current US$) in Guatemala and Aid flow (current US$) in Tajikistan?
Your answer should be very brief. 2.29e+07. In the year 1996, what is the difference between the Aid flow (current US$) of Middle East & North Africa (all income levels) and Aid flow (current US$) of Ghana?
Ensure brevity in your answer.  6.38e+08. In the year 1996, what is the difference between the Aid flow (current US$) in Middle East & North Africa (all income levels) and Aid flow (current US$) in Guatemala?
Offer a terse response. 6.45e+08. In the year 1996, what is the difference between the Aid flow (current US$) in Middle East & North Africa (all income levels) and Aid flow (current US$) in Tajikistan?
Your answer should be very brief. 6.69e+08. In the year 1996, what is the difference between the Aid flow (current US$) of Ghana and Aid flow (current US$) of Guatemala?
Offer a terse response. 7.81e+06. In the year 1996, what is the difference between the Aid flow (current US$) in Ghana and Aid flow (current US$) in Tajikistan?
Your response must be concise. 3.17e+07. In the year 1996, what is the difference between the Aid flow (current US$) of Guatemala and Aid flow (current US$) of Tajikistan?
Ensure brevity in your answer.  2.39e+07. In the year 1997, what is the difference between the Aid flow (current US$) of Middle East & North Africa (all income levels) and Aid flow (current US$) of Ghana?
Offer a very short reply. 5.79e+08. In the year 1997, what is the difference between the Aid flow (current US$) in Middle East & North Africa (all income levels) and Aid flow (current US$) in Guatemala?
Keep it short and to the point. 5.90e+08. In the year 1997, what is the difference between the Aid flow (current US$) of Middle East & North Africa (all income levels) and Aid flow (current US$) of Tajikistan?
Provide a short and direct response. 6.16e+08. In the year 1997, what is the difference between the Aid flow (current US$) in Ghana and Aid flow (current US$) in Guatemala?
Provide a succinct answer. 1.07e+07. In the year 1997, what is the difference between the Aid flow (current US$) in Ghana and Aid flow (current US$) in Tajikistan?
Your answer should be compact. 3.73e+07. In the year 1997, what is the difference between the Aid flow (current US$) in Guatemala and Aid flow (current US$) in Tajikistan?
Offer a terse response. 2.66e+07. In the year 1998, what is the difference between the Aid flow (current US$) in Middle East & North Africa (all income levels) and Aid flow (current US$) in Ghana?
Your response must be concise. 1.83e+08. In the year 1998, what is the difference between the Aid flow (current US$) in Middle East & North Africa (all income levels) and Aid flow (current US$) in Guatemala?
Offer a terse response. 1.91e+08. In the year 1998, what is the difference between the Aid flow (current US$) of Middle East & North Africa (all income levels) and Aid flow (current US$) of Tajikistan?
Keep it short and to the point. 2.12e+08. In the year 1998, what is the difference between the Aid flow (current US$) of Ghana and Aid flow (current US$) of Guatemala?
Provide a succinct answer. 7.85e+06. In the year 1998, what is the difference between the Aid flow (current US$) in Ghana and Aid flow (current US$) in Tajikistan?
Your answer should be compact. 2.87e+07. In the year 1998, what is the difference between the Aid flow (current US$) of Guatemala and Aid flow (current US$) of Tajikistan?
Provide a short and direct response. 2.09e+07. In the year 1999, what is the difference between the Aid flow (current US$) of Middle East & North Africa (all income levels) and Aid flow (current US$) of Ghana?
Provide a succinct answer. 2.27e+08. In the year 1999, what is the difference between the Aid flow (current US$) of Middle East & North Africa (all income levels) and Aid flow (current US$) of Guatemala?
Ensure brevity in your answer.  2.42e+08. In the year 1999, what is the difference between the Aid flow (current US$) in Middle East & North Africa (all income levels) and Aid flow (current US$) in Tajikistan?
Your response must be concise. 2.61e+08. In the year 1999, what is the difference between the Aid flow (current US$) of Ghana and Aid flow (current US$) of Guatemala?
Your response must be concise. 1.50e+07. In the year 1999, what is the difference between the Aid flow (current US$) of Ghana and Aid flow (current US$) of Tajikistan?
Your answer should be compact. 3.37e+07. In the year 1999, what is the difference between the Aid flow (current US$) in Guatemala and Aid flow (current US$) in Tajikistan?
Keep it short and to the point. 1.87e+07. What is the ratio of the Aid flow (current US$) in Middle East & North Africa (all income levels) in 1993 to that in 1994?
Your answer should be compact. 0.85. What is the ratio of the Aid flow (current US$) in Ghana in 1993 to that in 1994?
Your answer should be compact. 2.14. What is the ratio of the Aid flow (current US$) of Guatemala in 1993 to that in 1994?
Ensure brevity in your answer.  1.03. What is the ratio of the Aid flow (current US$) of Tajikistan in 1993 to that in 1994?
Give a very brief answer. 1.35. What is the ratio of the Aid flow (current US$) in Middle East & North Africa (all income levels) in 1993 to that in 1995?
Keep it short and to the point. 0.84. What is the ratio of the Aid flow (current US$) of Ghana in 1993 to that in 1995?
Offer a very short reply. 1.17. What is the ratio of the Aid flow (current US$) of Guatemala in 1993 to that in 1995?
Provide a succinct answer. 0.66. What is the ratio of the Aid flow (current US$) in Tajikistan in 1993 to that in 1995?
Offer a terse response. 0.16. What is the ratio of the Aid flow (current US$) in Middle East & North Africa (all income levels) in 1993 to that in 1996?
Offer a very short reply. 0.52. What is the ratio of the Aid flow (current US$) of Ghana in 1993 to that in 1996?
Offer a very short reply. 1.38. What is the ratio of the Aid flow (current US$) of Guatemala in 1993 to that in 1996?
Provide a short and direct response. 0.62. What is the ratio of the Aid flow (current US$) in Tajikistan in 1993 to that in 1996?
Give a very brief answer. 0.14. What is the ratio of the Aid flow (current US$) in Middle East & North Africa (all income levels) in 1993 to that in 1997?
Provide a succinct answer. 0.56. What is the ratio of the Aid flow (current US$) of Ghana in 1993 to that in 1997?
Your answer should be very brief. 1.21. What is the ratio of the Aid flow (current US$) of Guatemala in 1993 to that in 1997?
Keep it short and to the point. 0.58. What is the ratio of the Aid flow (current US$) in Tajikistan in 1993 to that in 1997?
Give a very brief answer. 0.14. What is the ratio of the Aid flow (current US$) of Middle East & North Africa (all income levels) in 1993 to that in 1998?
Your answer should be very brief. 1.62. What is the ratio of the Aid flow (current US$) in Ghana in 1993 to that in 1998?
Ensure brevity in your answer.  1.6. What is the ratio of the Aid flow (current US$) in Guatemala in 1993 to that in 1998?
Your response must be concise. 0.75. What is the ratio of the Aid flow (current US$) of Tajikistan in 1993 to that in 1998?
Your answer should be compact. 0.22. What is the ratio of the Aid flow (current US$) in Middle East & North Africa (all income levels) in 1993 to that in 1999?
Provide a succinct answer. 1.32. What is the ratio of the Aid flow (current US$) in Ghana in 1993 to that in 1999?
Your answer should be very brief. 1.36. What is the ratio of the Aid flow (current US$) of Guatemala in 1993 to that in 1999?
Give a very brief answer. 0.81. What is the ratio of the Aid flow (current US$) of Tajikistan in 1993 to that in 1999?
Offer a terse response. 0.19. What is the ratio of the Aid flow (current US$) of Middle East & North Africa (all income levels) in 1994 to that in 1995?
Your answer should be compact. 0.98. What is the ratio of the Aid flow (current US$) of Ghana in 1994 to that in 1995?
Offer a very short reply. 0.55. What is the ratio of the Aid flow (current US$) of Guatemala in 1994 to that in 1995?
Keep it short and to the point. 0.64. What is the ratio of the Aid flow (current US$) of Tajikistan in 1994 to that in 1995?
Your answer should be very brief. 0.12. What is the ratio of the Aid flow (current US$) in Middle East & North Africa (all income levels) in 1994 to that in 1996?
Make the answer very short. 0.61. What is the ratio of the Aid flow (current US$) of Ghana in 1994 to that in 1996?
Offer a terse response. 0.65. What is the ratio of the Aid flow (current US$) in Guatemala in 1994 to that in 1996?
Keep it short and to the point. 0.61. What is the ratio of the Aid flow (current US$) of Tajikistan in 1994 to that in 1996?
Provide a short and direct response. 0.1. What is the ratio of the Aid flow (current US$) of Middle East & North Africa (all income levels) in 1994 to that in 1997?
Make the answer very short. 0.66. What is the ratio of the Aid flow (current US$) in Ghana in 1994 to that in 1997?
Ensure brevity in your answer.  0.56. What is the ratio of the Aid flow (current US$) of Guatemala in 1994 to that in 1997?
Give a very brief answer. 0.56. What is the ratio of the Aid flow (current US$) in Tajikistan in 1994 to that in 1997?
Provide a short and direct response. 0.11. What is the ratio of the Aid flow (current US$) of Middle East & North Africa (all income levels) in 1994 to that in 1998?
Keep it short and to the point. 1.91. What is the ratio of the Aid flow (current US$) of Ghana in 1994 to that in 1998?
Offer a terse response. 0.75. What is the ratio of the Aid flow (current US$) in Guatemala in 1994 to that in 1998?
Offer a terse response. 0.73. What is the ratio of the Aid flow (current US$) in Tajikistan in 1994 to that in 1998?
Offer a terse response. 0.17. What is the ratio of the Aid flow (current US$) in Middle East & North Africa (all income levels) in 1994 to that in 1999?
Provide a short and direct response. 1.55. What is the ratio of the Aid flow (current US$) of Ghana in 1994 to that in 1999?
Ensure brevity in your answer.  0.64. What is the ratio of the Aid flow (current US$) in Guatemala in 1994 to that in 1999?
Keep it short and to the point. 0.78. What is the ratio of the Aid flow (current US$) in Tajikistan in 1994 to that in 1999?
Your answer should be very brief. 0.14. What is the ratio of the Aid flow (current US$) in Middle East & North Africa (all income levels) in 1995 to that in 1996?
Offer a very short reply. 0.62. What is the ratio of the Aid flow (current US$) in Ghana in 1995 to that in 1996?
Your answer should be compact. 1.18. What is the ratio of the Aid flow (current US$) of Guatemala in 1995 to that in 1996?
Your answer should be compact. 0.94. What is the ratio of the Aid flow (current US$) of Tajikistan in 1995 to that in 1996?
Offer a very short reply. 0.86. What is the ratio of the Aid flow (current US$) of Middle East & North Africa (all income levels) in 1995 to that in 1997?
Make the answer very short. 0.67. What is the ratio of the Aid flow (current US$) in Ghana in 1995 to that in 1997?
Your response must be concise. 1.03. What is the ratio of the Aid flow (current US$) of Guatemala in 1995 to that in 1997?
Your answer should be very brief. 0.87. What is the ratio of the Aid flow (current US$) in Tajikistan in 1995 to that in 1997?
Provide a succinct answer. 0.9. What is the ratio of the Aid flow (current US$) in Middle East & North Africa (all income levels) in 1995 to that in 1998?
Give a very brief answer. 1.94. What is the ratio of the Aid flow (current US$) in Ghana in 1995 to that in 1998?
Give a very brief answer. 1.36. What is the ratio of the Aid flow (current US$) of Guatemala in 1995 to that in 1998?
Offer a very short reply. 1.14. What is the ratio of the Aid flow (current US$) of Tajikistan in 1995 to that in 1998?
Your answer should be very brief. 1.39. What is the ratio of the Aid flow (current US$) in Middle East & North Africa (all income levels) in 1995 to that in 1999?
Offer a very short reply. 1.57. What is the ratio of the Aid flow (current US$) of Ghana in 1995 to that in 1999?
Your response must be concise. 1.16. What is the ratio of the Aid flow (current US$) in Guatemala in 1995 to that in 1999?
Provide a short and direct response. 1.22. What is the ratio of the Aid flow (current US$) in Tajikistan in 1995 to that in 1999?
Offer a terse response. 1.18. What is the ratio of the Aid flow (current US$) of Middle East & North Africa (all income levels) in 1996 to that in 1997?
Offer a terse response. 1.09. What is the ratio of the Aid flow (current US$) in Ghana in 1996 to that in 1997?
Offer a very short reply. 0.87. What is the ratio of the Aid flow (current US$) of Guatemala in 1996 to that in 1997?
Offer a very short reply. 0.92. What is the ratio of the Aid flow (current US$) of Tajikistan in 1996 to that in 1997?
Provide a short and direct response. 1.05. What is the ratio of the Aid flow (current US$) of Middle East & North Africa (all income levels) in 1996 to that in 1998?
Ensure brevity in your answer.  3.14. What is the ratio of the Aid flow (current US$) of Ghana in 1996 to that in 1998?
Provide a succinct answer. 1.16. What is the ratio of the Aid flow (current US$) of Guatemala in 1996 to that in 1998?
Your answer should be compact. 1.21. What is the ratio of the Aid flow (current US$) of Tajikistan in 1996 to that in 1998?
Make the answer very short. 1.62. What is the ratio of the Aid flow (current US$) of Middle East & North Africa (all income levels) in 1996 to that in 1999?
Keep it short and to the point. 2.55. What is the ratio of the Aid flow (current US$) of Ghana in 1996 to that in 1999?
Make the answer very short. 0.99. What is the ratio of the Aid flow (current US$) in Guatemala in 1996 to that in 1999?
Keep it short and to the point. 1.29. What is the ratio of the Aid flow (current US$) of Tajikistan in 1996 to that in 1999?
Your answer should be very brief. 1.37. What is the ratio of the Aid flow (current US$) in Middle East & North Africa (all income levels) in 1997 to that in 1998?
Provide a short and direct response. 2.89. What is the ratio of the Aid flow (current US$) of Ghana in 1997 to that in 1998?
Your response must be concise. 1.32. What is the ratio of the Aid flow (current US$) of Guatemala in 1997 to that in 1998?
Ensure brevity in your answer.  1.31. What is the ratio of the Aid flow (current US$) of Tajikistan in 1997 to that in 1998?
Provide a short and direct response. 1.55. What is the ratio of the Aid flow (current US$) of Middle East & North Africa (all income levels) in 1997 to that in 1999?
Provide a short and direct response. 2.35. What is the ratio of the Aid flow (current US$) in Ghana in 1997 to that in 1999?
Offer a terse response. 1.13. What is the ratio of the Aid flow (current US$) in Guatemala in 1997 to that in 1999?
Provide a succinct answer. 1.41. What is the ratio of the Aid flow (current US$) in Tajikistan in 1997 to that in 1999?
Give a very brief answer. 1.31. What is the ratio of the Aid flow (current US$) in Middle East & North Africa (all income levels) in 1998 to that in 1999?
Ensure brevity in your answer.  0.81. What is the ratio of the Aid flow (current US$) of Ghana in 1998 to that in 1999?
Your answer should be very brief. 0.85. What is the ratio of the Aid flow (current US$) in Guatemala in 1998 to that in 1999?
Your answer should be compact. 1.07. What is the ratio of the Aid flow (current US$) of Tajikistan in 1998 to that in 1999?
Give a very brief answer. 0.85. What is the difference between the highest and the second highest Aid flow (current US$) of Middle East & North Africa (all income levels)?
Offer a very short reply. 5.32e+07. What is the difference between the highest and the second highest Aid flow (current US$) of Ghana?
Keep it short and to the point. 7.49e+06. What is the difference between the highest and the second highest Aid flow (current US$) of Guatemala?
Your answer should be compact. 2.49e+06. What is the difference between the highest and the lowest Aid flow (current US$) in Middle East & North Africa (all income levels)?
Keep it short and to the point. 4.59e+08. What is the difference between the highest and the lowest Aid flow (current US$) in Ghana?
Your answer should be compact. 2.73e+07. What is the difference between the highest and the lowest Aid flow (current US$) of Guatemala?
Your response must be concise. 1.40e+07. What is the difference between the highest and the lowest Aid flow (current US$) of Tajikistan?
Offer a very short reply. 4.82e+06. 